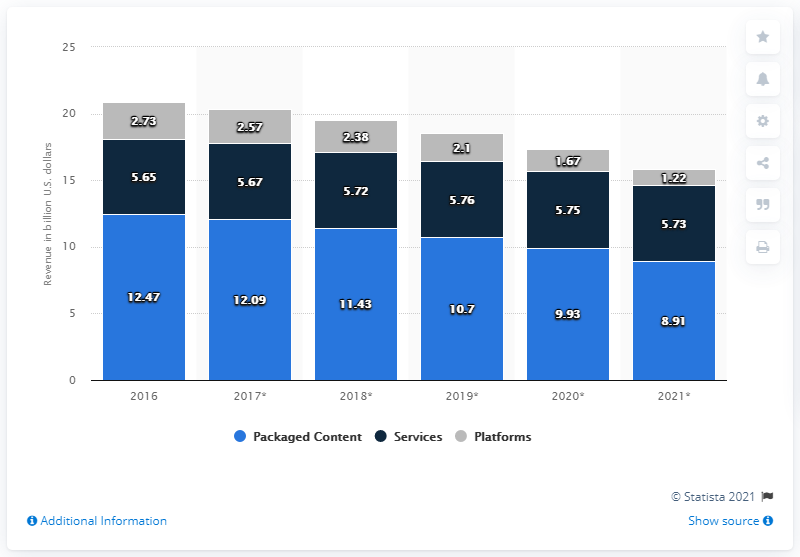Mention a couple of crucial points in this snapshot. By 2021, packaged retail self-paced content in the U.S. is projected to generate a revenue of approximately $8.91 billion. In the United States in 2016, packaged retail self-paced content generated approximately 12.47 billion in revenue. 